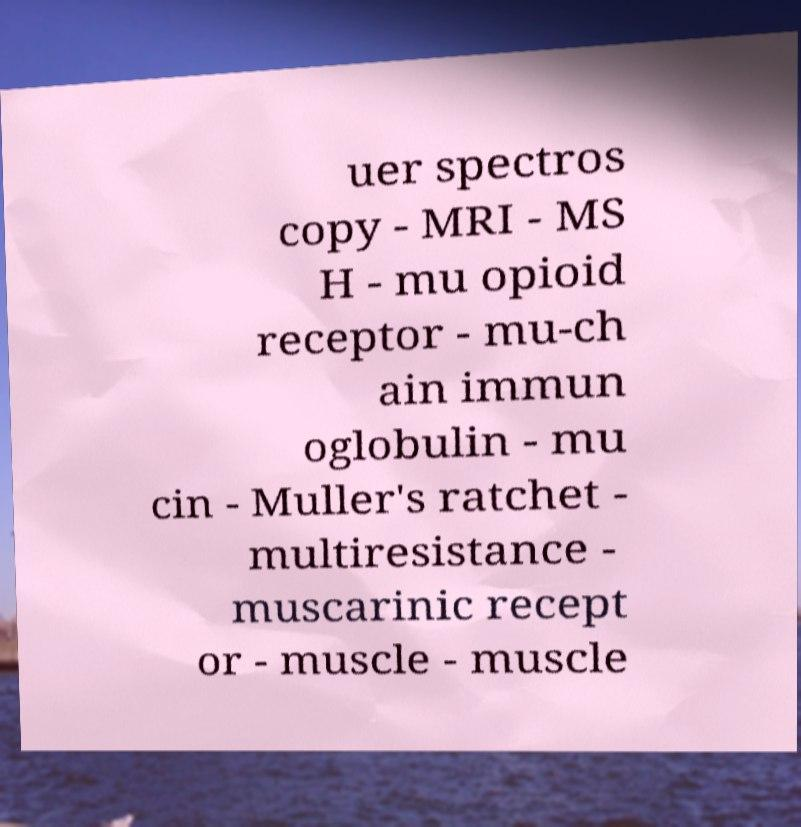Can you accurately transcribe the text from the provided image for me? uer spectros copy - MRI - MS H - mu opioid receptor - mu-ch ain immun oglobulin - mu cin - Muller's ratchet - multiresistance - muscarinic recept or - muscle - muscle 